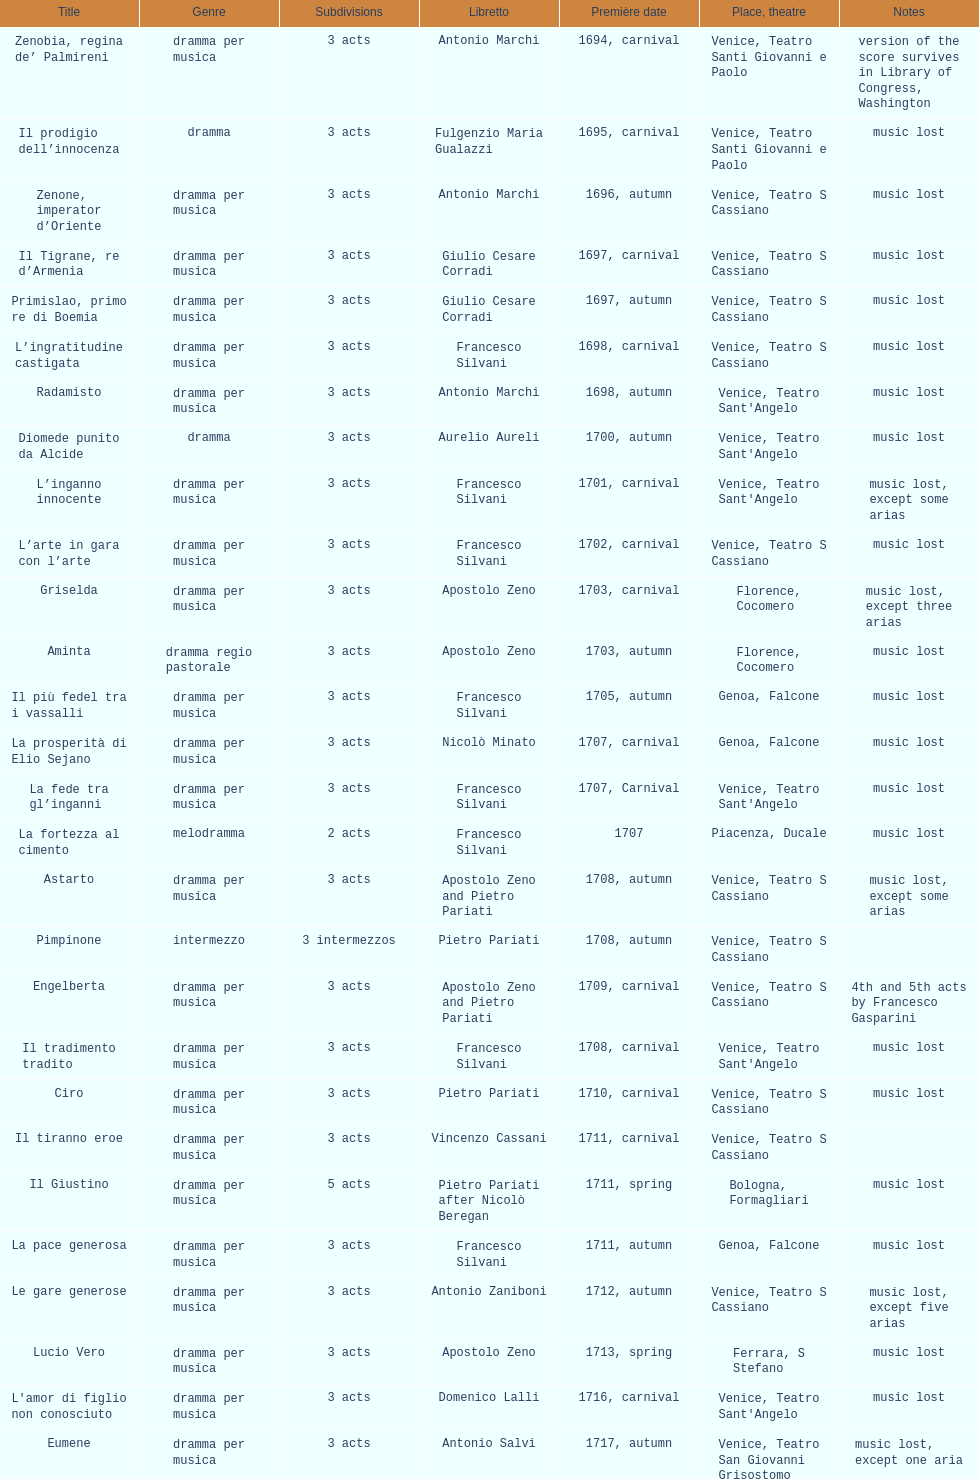Help me parse the entirety of this table. {'header': ['Title', 'Genre', 'Sub\xaddivisions', 'Libretto', 'Première date', 'Place, theatre', 'Notes'], 'rows': [['Zenobia, regina de’ Palmireni', 'dramma per musica', '3 acts', 'Antonio Marchi', '1694, carnival', 'Venice, Teatro Santi Giovanni e Paolo', 'version of the score survives in Library of Congress, Washington'], ['Il prodigio dell’innocenza', 'dramma', '3 acts', 'Fulgenzio Maria Gualazzi', '1695, carnival', 'Venice, Teatro Santi Giovanni e Paolo', 'music lost'], ['Zenone, imperator d’Oriente', 'dramma per musica', '3 acts', 'Antonio Marchi', '1696, autumn', 'Venice, Teatro S Cassiano', 'music lost'], ['Il Tigrane, re d’Armenia', 'dramma per musica', '3 acts', 'Giulio Cesare Corradi', '1697, carnival', 'Venice, Teatro S Cassiano', 'music lost'], ['Primislao, primo re di Boemia', 'dramma per musica', '3 acts', 'Giulio Cesare Corradi', '1697, autumn', 'Venice, Teatro S Cassiano', 'music lost'], ['L’ingratitudine castigata', 'dramma per musica', '3 acts', 'Francesco Silvani', '1698, carnival', 'Venice, Teatro S Cassiano', 'music lost'], ['Radamisto', 'dramma per musica', '3 acts', 'Antonio Marchi', '1698, autumn', "Venice, Teatro Sant'Angelo", 'music lost'], ['Diomede punito da Alcide', 'dramma', '3 acts', 'Aurelio Aureli', '1700, autumn', "Venice, Teatro Sant'Angelo", 'music lost'], ['L’inganno innocente', 'dramma per musica', '3 acts', 'Francesco Silvani', '1701, carnival', "Venice, Teatro Sant'Angelo", 'music lost, except some arias'], ['L’arte in gara con l’arte', 'dramma per musica', '3 acts', 'Francesco Silvani', '1702, carnival', 'Venice, Teatro S Cassiano', 'music lost'], ['Griselda', 'dramma per musica', '3 acts', 'Apostolo Zeno', '1703, carnival', 'Florence, Cocomero', 'music lost, except three arias'], ['Aminta', 'dramma regio pastorale', '3 acts', 'Apostolo Zeno', '1703, autumn', 'Florence, Cocomero', 'music lost'], ['Il più fedel tra i vassalli', 'dramma per musica', '3 acts', 'Francesco Silvani', '1705, autumn', 'Genoa, Falcone', 'music lost'], ['La prosperità di Elio Sejano', 'dramma per musica', '3 acts', 'Nicolò Minato', '1707, carnival', 'Genoa, Falcone', 'music lost'], ['La fede tra gl’inganni', 'dramma per musica', '3 acts', 'Francesco Silvani', '1707, Carnival', "Venice, Teatro Sant'Angelo", 'music lost'], ['La fortezza al cimento', 'melodramma', '2 acts', 'Francesco Silvani', '1707', 'Piacenza, Ducale', 'music lost'], ['Astarto', 'dramma per musica', '3 acts', 'Apostolo Zeno and Pietro Pariati', '1708, autumn', 'Venice, Teatro S Cassiano', 'music lost, except some arias'], ['Pimpinone', 'intermezzo', '3 intermezzos', 'Pietro Pariati', '1708, autumn', 'Venice, Teatro S Cassiano', ''], ['Engelberta', 'dramma per musica', '3 acts', 'Apostolo Zeno and Pietro Pariati', '1709, carnival', 'Venice, Teatro S Cassiano', '4th and 5th acts by Francesco Gasparini'], ['Il tradimento tradito', 'dramma per musica', '3 acts', 'Francesco Silvani', '1708, carnival', "Venice, Teatro Sant'Angelo", 'music lost'], ['Ciro', 'dramma per musica', '3 acts', 'Pietro Pariati', '1710, carnival', 'Venice, Teatro S Cassiano', 'music lost'], ['Il tiranno eroe', 'dramma per musica', '3 acts', 'Vincenzo Cassani', '1711, carnival', 'Venice, Teatro S Cassiano', ''], ['Il Giustino', 'dramma per musica', '5 acts', 'Pietro Pariati after Nicolò Beregan', '1711, spring', 'Bologna, Formagliari', 'music lost'], ['La pace generosa', 'dramma per musica', '3 acts', 'Francesco Silvani', '1711, autumn', 'Genoa, Falcone', 'music lost'], ['Le gare generose', 'dramma per musica', '3 acts', 'Antonio Zaniboni', '1712, autumn', 'Venice, Teatro S Cassiano', 'music lost, except five arias'], ['Lucio Vero', 'dramma per musica', '3 acts', 'Apostolo Zeno', '1713, spring', 'Ferrara, S Stefano', 'music lost'], ["L'amor di figlio non conosciuto", 'dramma per musica', '3 acts', 'Domenico Lalli', '1716, carnival', "Venice, Teatro Sant'Angelo", 'music lost'], ['Eumene', 'dramma per musica', '3 acts', 'Antonio Salvi', '1717, autumn', 'Venice, Teatro San Giovanni Grisostomo', 'music lost, except one aria'], ['Meleagro', 'dramma per musica', '3 acts', 'Pietro Antonio Bernardoni', '1718, carnival', "Venice, Teatro Sant'Angelo", 'music lost'], ['Cleomene', 'dramma per musica', '3 acts', 'Vincenzo Cassani', '1718, carnival', "Venice, Teatro Sant'Angelo", 'music lost'], ['Gli eccessi della gelosia', 'dramma per musica', '3 acts', 'Domenico Lalli', '1722, carnival', "Venice, Teatro Sant'Angelo", 'music lost, except some arias'], ['I veri amici', 'dramma per musica', '3 acts', 'Francesco Silvani and Domenico Lalli after Pierre Corneille', '1722, October', 'Munich, Hof', 'music lost, except some arias'], ['Il trionfo d’amore', 'dramma per musica', '3 acts', 'Pietro Pariati', '1722, November', 'Munich', 'music lost'], ['Eumene', 'dramma per musica', '3 acts', 'Apostolo Zeno', '1723, carnival', 'Venice, Teatro San Moisè', 'music lost, except 2 arias'], ['Ermengarda', 'dramma per musica', '3 acts', 'Antonio Maria Lucchini', '1723, autumn', 'Venice, Teatro San Moisè', 'music lost'], ['Antigono, tutore di Filippo, re di Macedonia', 'tragedia', '5 acts', 'Giovanni Piazzon', '1724, carnival', 'Venice, Teatro San Moisè', '5th act by Giovanni Porta, music lost'], ['Scipione nelle Spagne', 'dramma per musica', '3 acts', 'Apostolo Zeno', '1724, Ascension', 'Venice, Teatro San Samuele', 'music lost'], ['Laodice', 'dramma per musica', '3 acts', 'Angelo Schietti', '1724, autumn', 'Venice, Teatro San Moisè', 'music lost, except 2 arias'], ['Didone abbandonata', 'tragedia', '3 acts', 'Metastasio', '1725, carnival', 'Venice, Teatro S Cassiano', 'music lost'], ["L'impresario delle Isole Canarie", 'intermezzo', '2 acts', 'Metastasio', '1725, carnival', 'Venice, Teatro S Cassiano', 'music lost'], ['Alcina delusa da Ruggero', 'dramma per musica', '3 acts', 'Antonio Marchi', '1725, autumn', 'Venice, Teatro S Cassiano', 'music lost'], ['I rivali generosi', 'dramma per musica', '3 acts', 'Apostolo Zeno', '1725', 'Brescia, Nuovo', ''], ['La Statira', 'dramma per musica', '3 acts', 'Apostolo Zeno and Pietro Pariati', '1726, Carnival', 'Rome, Teatro Capranica', ''], ['Malsazio e Fiammetta', 'intermezzo', '', '', '1726, Carnival', 'Rome, Teatro Capranica', ''], ['Il trionfo di Armida', 'dramma per musica', '3 acts', 'Girolamo Colatelli after Torquato Tasso', '1726, autumn', 'Venice, Teatro San Moisè', 'music lost'], ['L’incostanza schernita', 'dramma comico-pastorale', '3 acts', 'Vincenzo Cassani', '1727, Ascension', 'Venice, Teatro San Samuele', 'music lost, except some arias'], ['Le due rivali in amore', 'dramma per musica', '3 acts', 'Aurelio Aureli', '1728, autumn', 'Venice, Teatro San Moisè', 'music lost'], ['Il Satrapone', 'intermezzo', '', 'Salvi', '1729', 'Parma, Omodeo', ''], ['Li stratagemmi amorosi', 'dramma per musica', '3 acts', 'F Passerini', '1730, carnival', 'Venice, Teatro San Moisè', 'music lost'], ['Elenia', 'dramma per musica', '3 acts', 'Luisa Bergalli', '1730, carnival', "Venice, Teatro Sant'Angelo", 'music lost'], ['Merope', 'dramma', '3 acts', 'Apostolo Zeno', '1731, autumn', 'Prague, Sporck Theater', 'mostly by Albinoni, music lost'], ['Il più infedel tra gli amanti', 'dramma per musica', '3 acts', 'Angelo Schietti', '1731, autumn', 'Treviso, Dolphin', 'music lost'], ['Ardelinda', 'dramma', '3 acts', 'Bartolomeo Vitturi', '1732, autumn', "Venice, Teatro Sant'Angelo", 'music lost, except five arias'], ['Candalide', 'dramma per musica', '3 acts', 'Bartolomeo Vitturi', '1734, carnival', "Venice, Teatro Sant'Angelo", 'music lost'], ['Artamene', 'dramma per musica', '3 acts', 'Bartolomeo Vitturi', '1741, carnival', "Venice, Teatro Sant'Angelo", 'music lost']]} Following zenone, imperator d'oriente, how many were released? 52. 